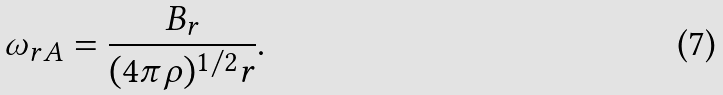<formula> <loc_0><loc_0><loc_500><loc_500>\omega _ { r A } = \frac { B _ { r } } { ( 4 \pi \rho ) ^ { 1 / 2 } r } .</formula> 